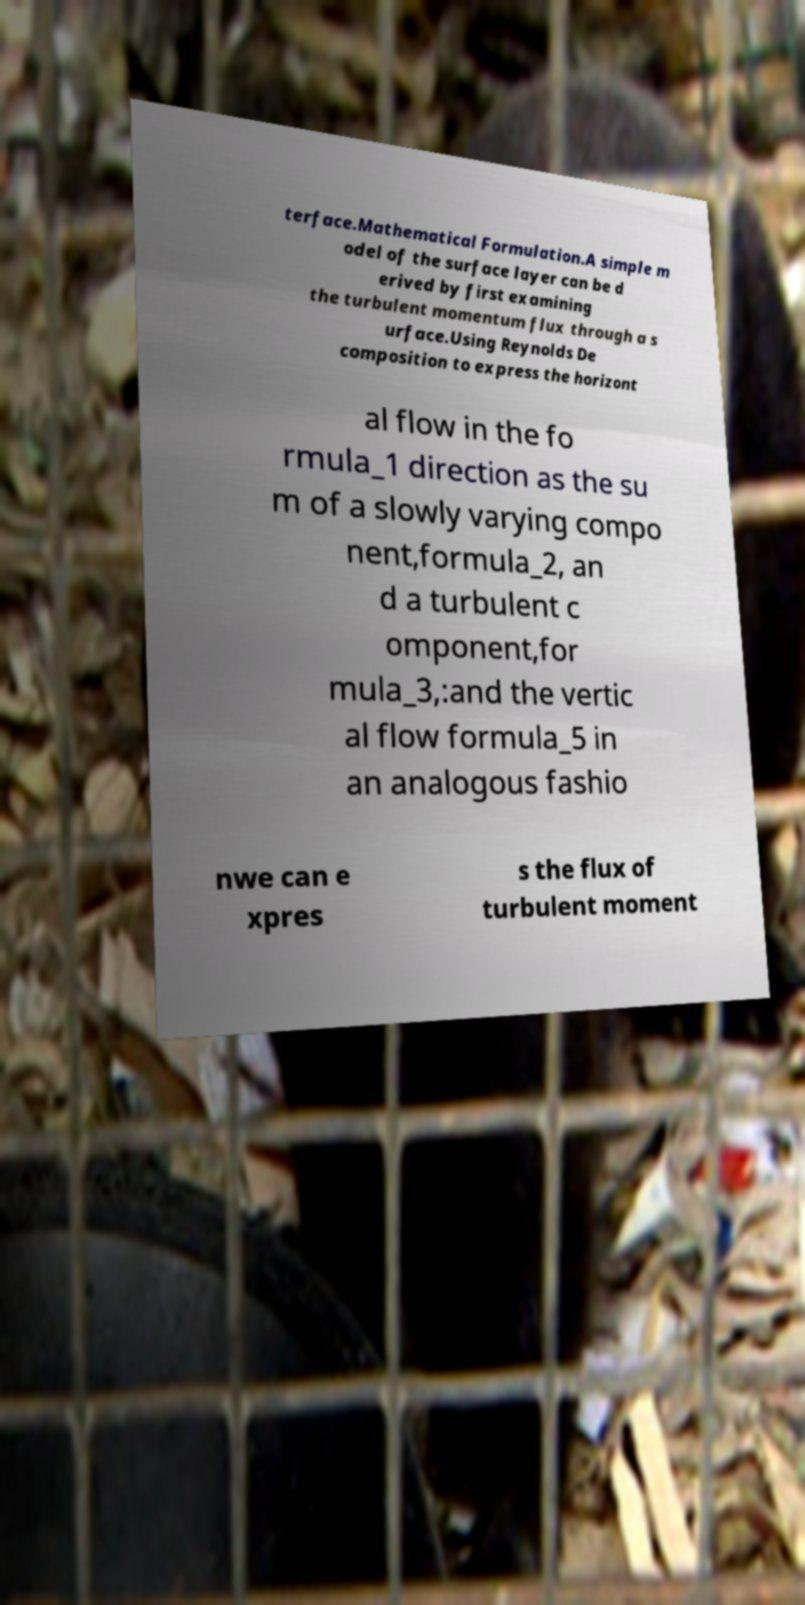Please identify and transcribe the text found in this image. terface.Mathematical Formulation.A simple m odel of the surface layer can be d erived by first examining the turbulent momentum flux through a s urface.Using Reynolds De composition to express the horizont al flow in the fo rmula_1 direction as the su m of a slowly varying compo nent,formula_2, an d a turbulent c omponent,for mula_3,:and the vertic al flow formula_5 in an analogous fashio nwe can e xpres s the flux of turbulent moment 